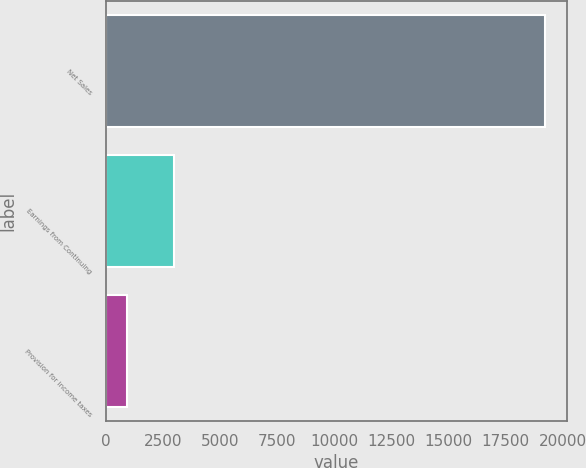Convert chart to OTSL. <chart><loc_0><loc_0><loc_500><loc_500><bar_chart><fcel>Net Sales<fcel>Earnings from Continuing<fcel>Provision for income taxes<nl><fcel>19207<fcel>2992<fcel>932<nl></chart> 